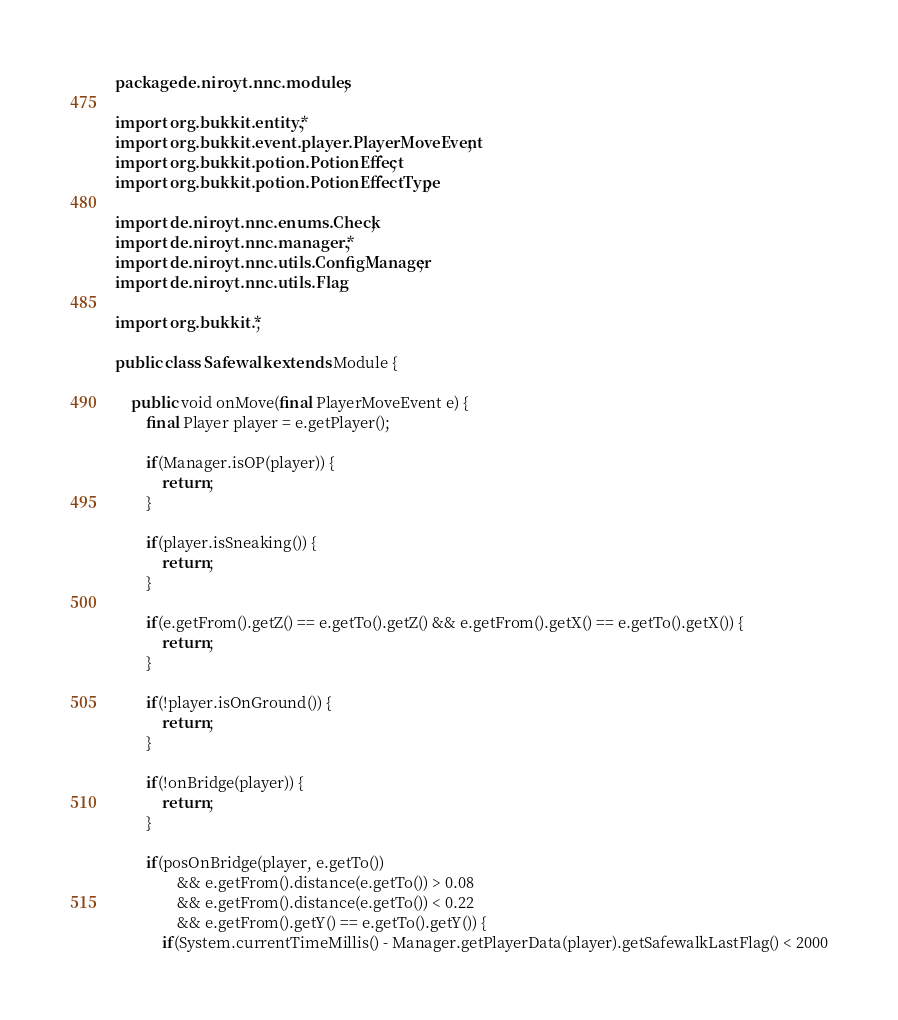Convert code to text. <code><loc_0><loc_0><loc_500><loc_500><_Java_>package de.niroyt.nnc.modules;

import org.bukkit.entity.*;
import org.bukkit.event.player.PlayerMoveEvent;
import org.bukkit.potion.PotionEffect;
import org.bukkit.potion.PotionEffectType;

import de.niroyt.nnc.enums.Check;
import de.niroyt.nnc.manager.*;
import de.niroyt.nnc.utils.ConfigManager;
import de.niroyt.nnc.utils.Flag;

import org.bukkit.*;

public class Safewalk extends Module {
	        
    public void onMove(final PlayerMoveEvent e) {    	
    	final Player player = e.getPlayer();
    	
    	if(Manager.isOP(player)) {
        	return;
        }
    	
    	if(player.isSneaking()) {
    		return;
    	}
    	
    	if(e.getFrom().getZ() == e.getTo().getZ() && e.getFrom().getX() == e.getTo().getX()) {
    		return;
    	}
    	
    	if(!player.isOnGround()) {
    		return;
    	}
    	
    	if(!onBridge(player)) {
    		return;
    	}
    	
    	if(posOnBridge(player, e.getTo()) 
    			&& e.getFrom().distance(e.getTo()) > 0.08
    			&& e.getFrom().distance(e.getTo()) < 0.22
    			&& e.getFrom().getY() == e.getTo().getY()) {        		
    		if(System.currentTimeMillis() - Manager.getPlayerData(player).getSafewalkLastFlag() < 2000</code> 